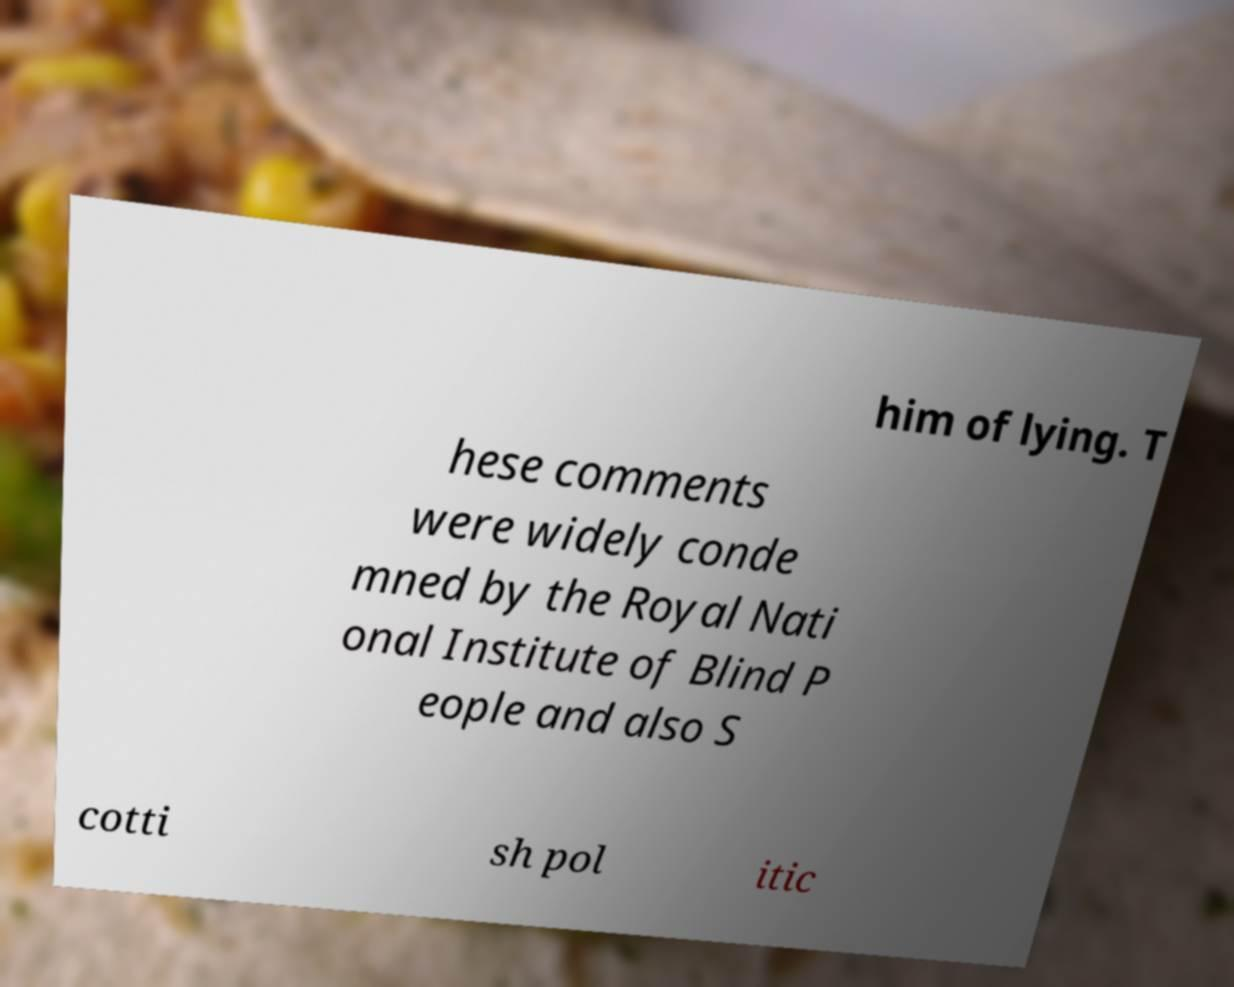Can you read and provide the text displayed in the image?This photo seems to have some interesting text. Can you extract and type it out for me? him of lying. T hese comments were widely conde mned by the Royal Nati onal Institute of Blind P eople and also S cotti sh pol itic 